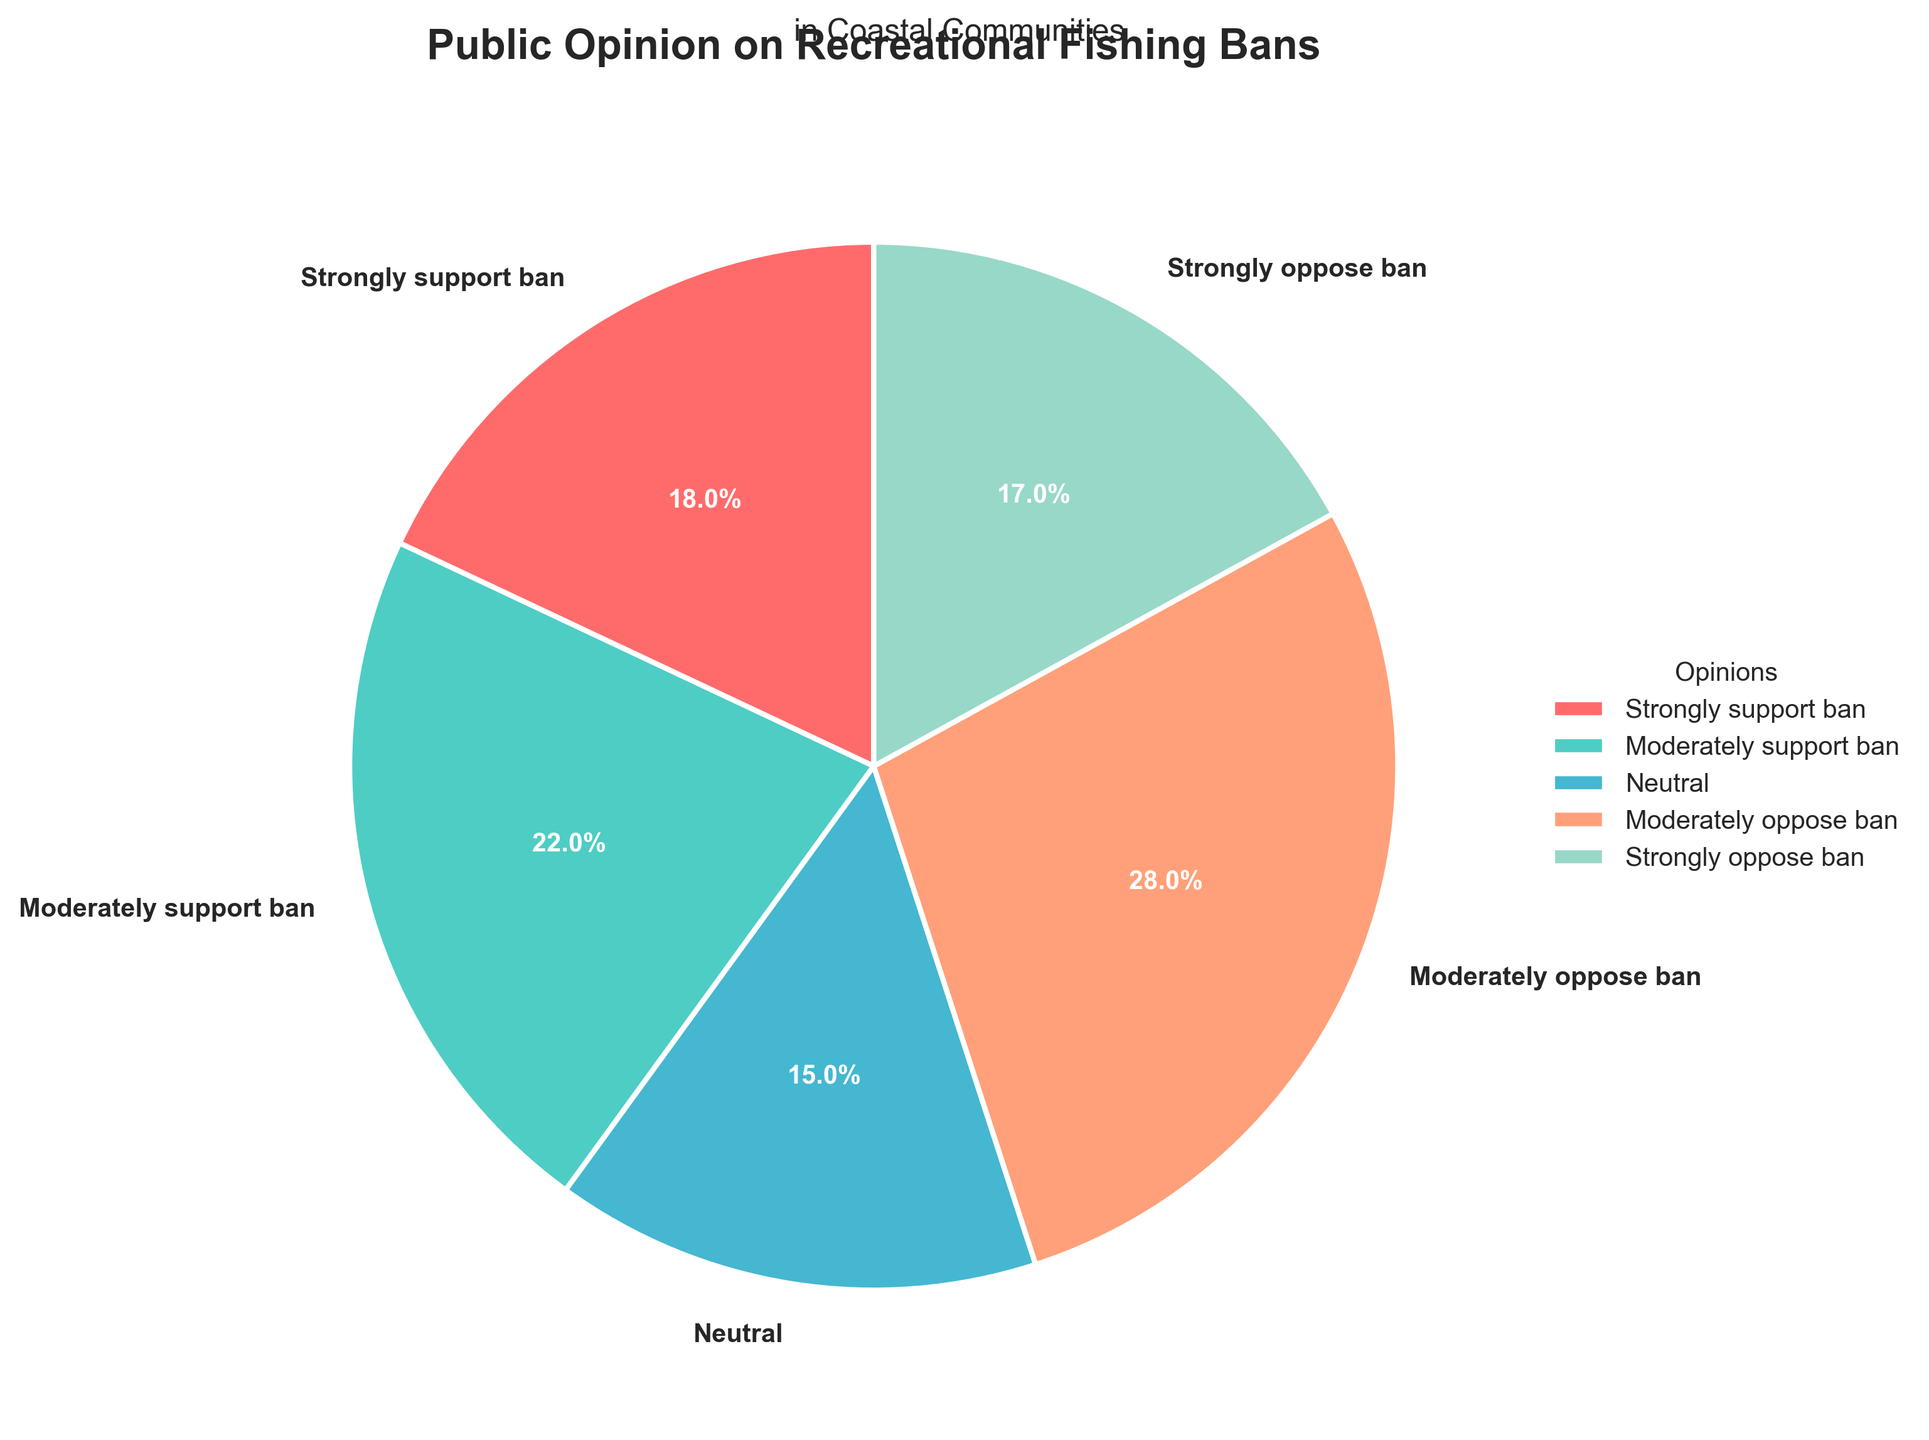Which opinion category has the smallest percentage? By looking at the pie chart, you can identify the smallest wedge, which represents the category with the smallest percentage. The "Strongly support ban" category has the smallest percentage at 18%.
Answer: Strongly support ban Which two opinion categories have the highest combined percentage? To find the combined percentage, identify the two largest wedges and add their percentages together. The two largest categories are "Moderately oppose ban" (28%) and "Moderately support ban" (22%), which together make 50%.
Answer: Moderately oppose ban and Moderately support ban What is the difference in percentage between "Moderately support ban" and "Moderately oppose ban"? Subtract the percentage of "Moderately support ban" (22%) from "Moderately oppose ban" (28%): 28% - 22% = 6%.
Answer: 6% What is the total percentage of people who support the ban (both strongly and moderately)? Add the percentages of "Strongly support ban" (18%) and "Moderately support ban" (22%): 18% + 22% = 40%.
Answer: 40% Which opinion category comes second in terms of support for the ban? After identifying the percentage values for support categories, "Moderately support ban" at 22% is the second-highest.
Answer: Moderately support ban How many categories together make up less than 40% of the opinions? Identify categories that individually account for less than 40% and sum the counts. "Strongly support ban" (18%), "Neutral" (15%), and "Strongly oppose ban" (17%) each have less than 40%, totaling three categories.
Answer: Three What percentage of the opinions is neutral? Locate the wedge labeled "Neutral" to see its percentage value. The pie chart shows that 15% of the opinions are neutral.
Answer: 15% Is the percentage of people who strongly oppose the ban greater than those who strongly support the ban? Compare the percentages of the two categories. "Strongly oppose ban" at 17% is just slightly smaller than "Strongly support ban" at 18%.
Answer: No Which colored wedge has the largest representation in the pie chart? Observe the pie chart and identify which wedge is visually the largest. The blue wedge, representing "Moderately oppose ban," is the largest at 28%.
Answer: Blue How significant is the difference between "Strongly support ban" and "Neutral"? Find the absolute difference by subtracting the smaller percentage from the larger one: 18% - 15% = 3%.
Answer: 3% 